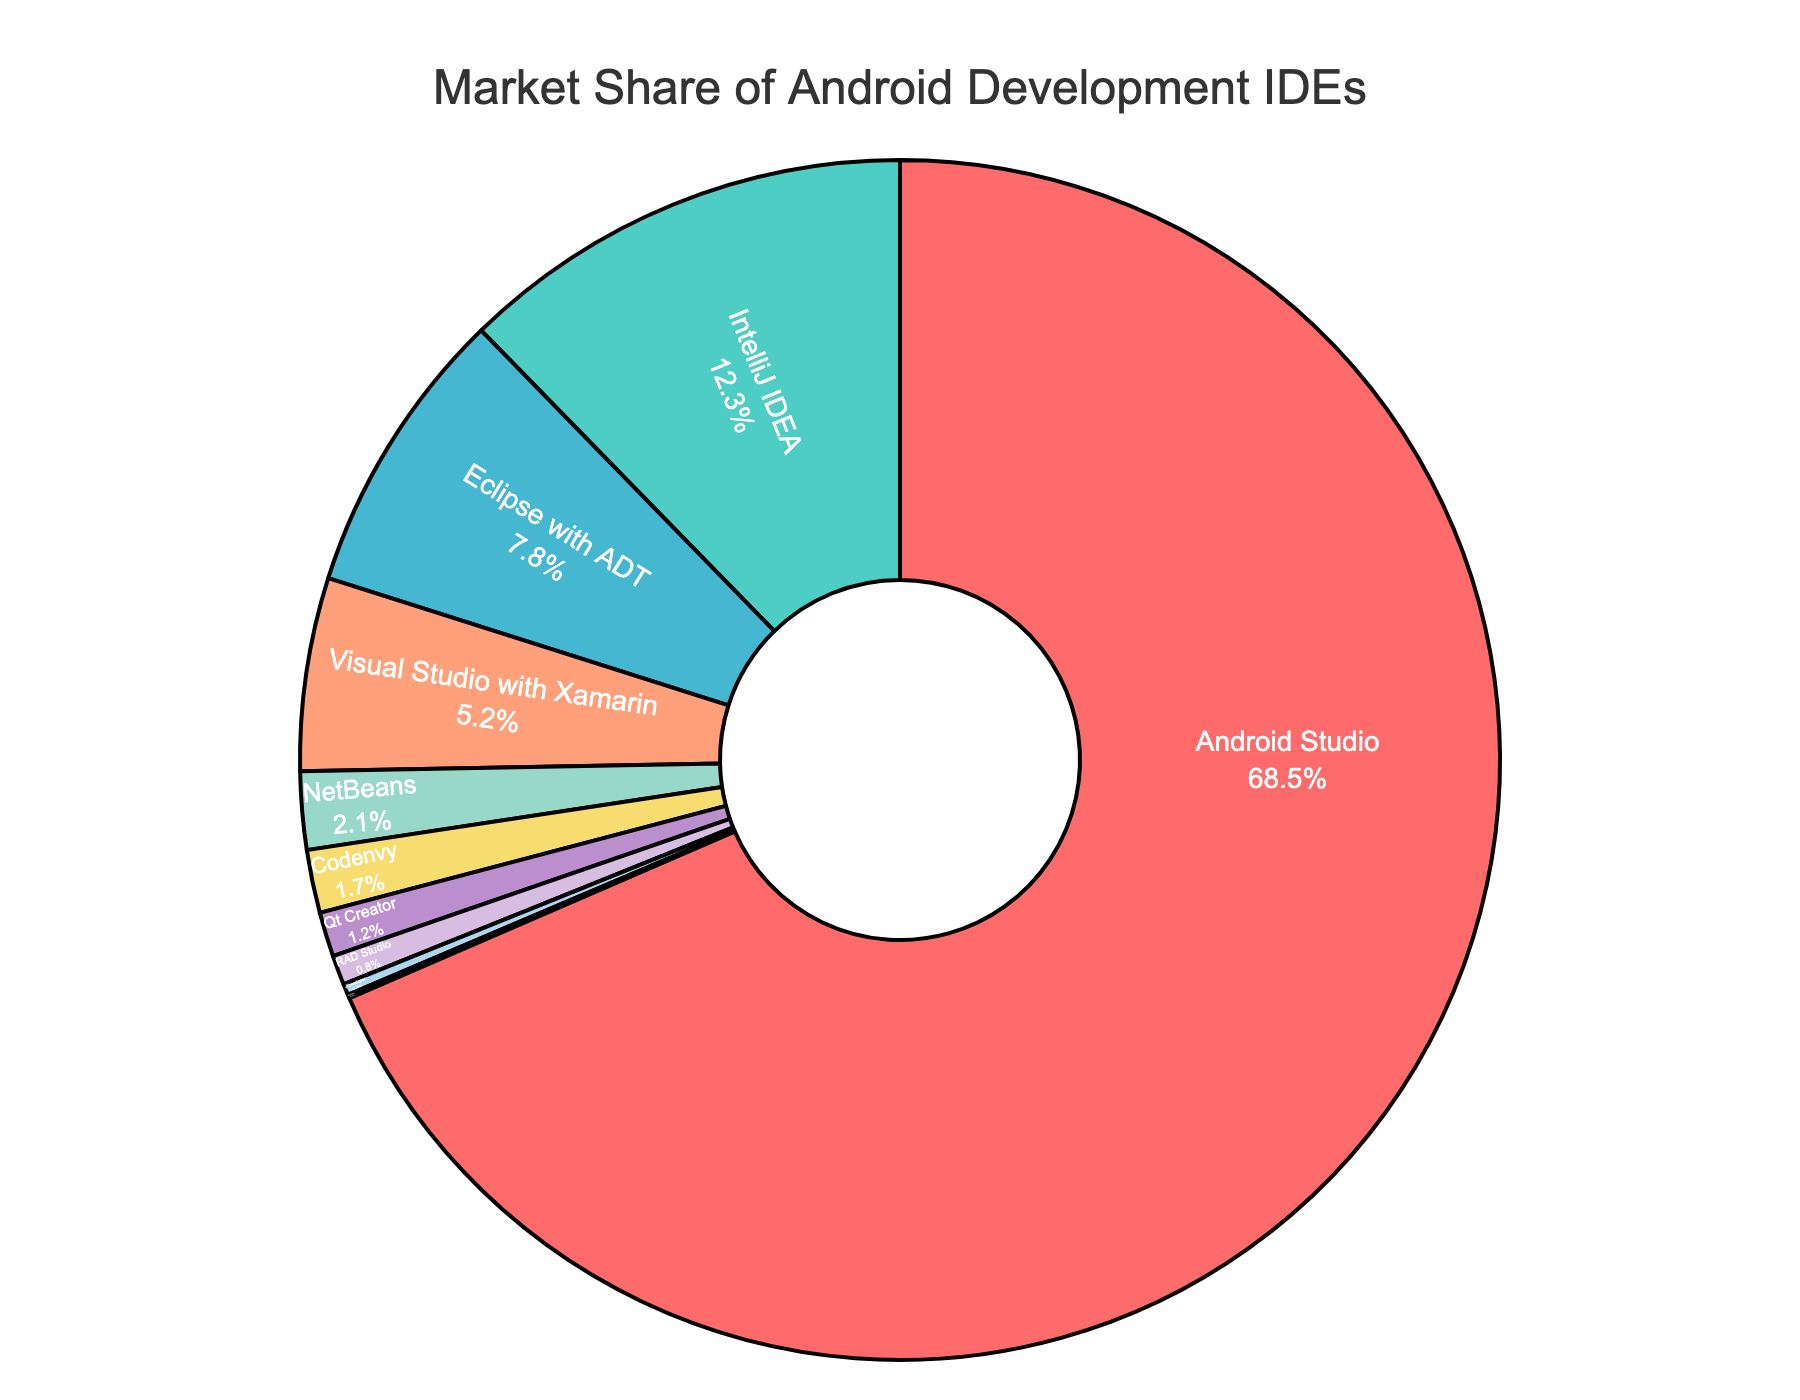What is the IDE with the largest market share? According to the pie chart, we can see that the IDE with the largest segment is Android Studio. Its percentage share is also shown in the figure as 68.5%.
Answer: Android Studio Which IDE has a market share of less than 1%? By looking at the smaller segments of the pie chart, you can see that RAD Studio, JDeveloper, and PhpStorm each have market shares of less than 1%, evidenced by their tiny portions in the chart. Specifically, RAD Studio has 0.8%, JDeveloper has 0.3%, and PhpStorm has 0.1%.
Answer: RAD Studio, JDeveloper, PhpStorm How much larger is Android Studio's market share compared to IntelliJ IDEA's? Android Studio has a market share of 68.5%, while IntelliJ IDEA has a market share of 12.3%. The difference in their market shares is 68.5% - 12.3% = 56.2%.
Answer: 56.2% What is the combined market share of Eclipse with ADT and Visual Studio with Xamarin? Referring to the percentages shown in the pie chart, Eclipse with ADT has 7.8% and Visual Studio with Xamarin has 5.2%. Adding these together we get 7.8% + 5.2% = 13.0%.
Answer: 13.0% Which IDEs have a market share higher than 10%? Observing the pie chart, the only IDEs with segments showing percentages higher than 10% are Android Studio (68.5%) and IntelliJ IDEA (12.3%).
Answer: Android Studio, IntelliJ IDEA How does the market share of NetBeans compare to that of Codenvy? Looking at the corresponding segments, NetBeans has a market share of 2.1%, while Codenvy's share is 1.7%. Therefore, NetBeans has a higher market share compared to Codenvy.
Answer: NetBeans has a higher market share What is the total market share of IDEs with a share greater than 5% but less than 20%? From the pie chart, IntelliJ IDEA has a market share of 12.3%, Eclipse with ADT has 7.8%, and Visual Studio with Xamarin has 5.2%. Summing their shares gives 12.3% + 7.8% + 5.2% = 25.3%.
Answer: 25.3% Which IDE occupies a portion of the pie that is colored green? Referring to the color assignment, the second largest section, colored green, represents IntelliJ IDEA with a market share of 12.3%.
Answer: IntelliJ IDEA How many IDEs have a market share between 1% and 10%? The IDEs with market shares within this range are Eclipse with ADT (7.8%), Visual Studio with Xamarin (5.2%), NetBeans (2.1%), and Codenvy (1.7%). Therefore, there are four IDEs that fall into this range.
Answer: Four IDEs What is the average market share of all IDEs listed in the pie chart? To find the average market share of the listed IDEs, we sum all market shares and divide by the number of IDEs. The total sum is 68.5 + 12.3 + 7.8 + 5.2 + 2.1 + 1.7 + 1.2 + 0.8 + 0.3 + 0.1 = 100%. There are 10 IDEs in the list, so the average market share is 100% / 10 = 10%.
Answer: 10% 